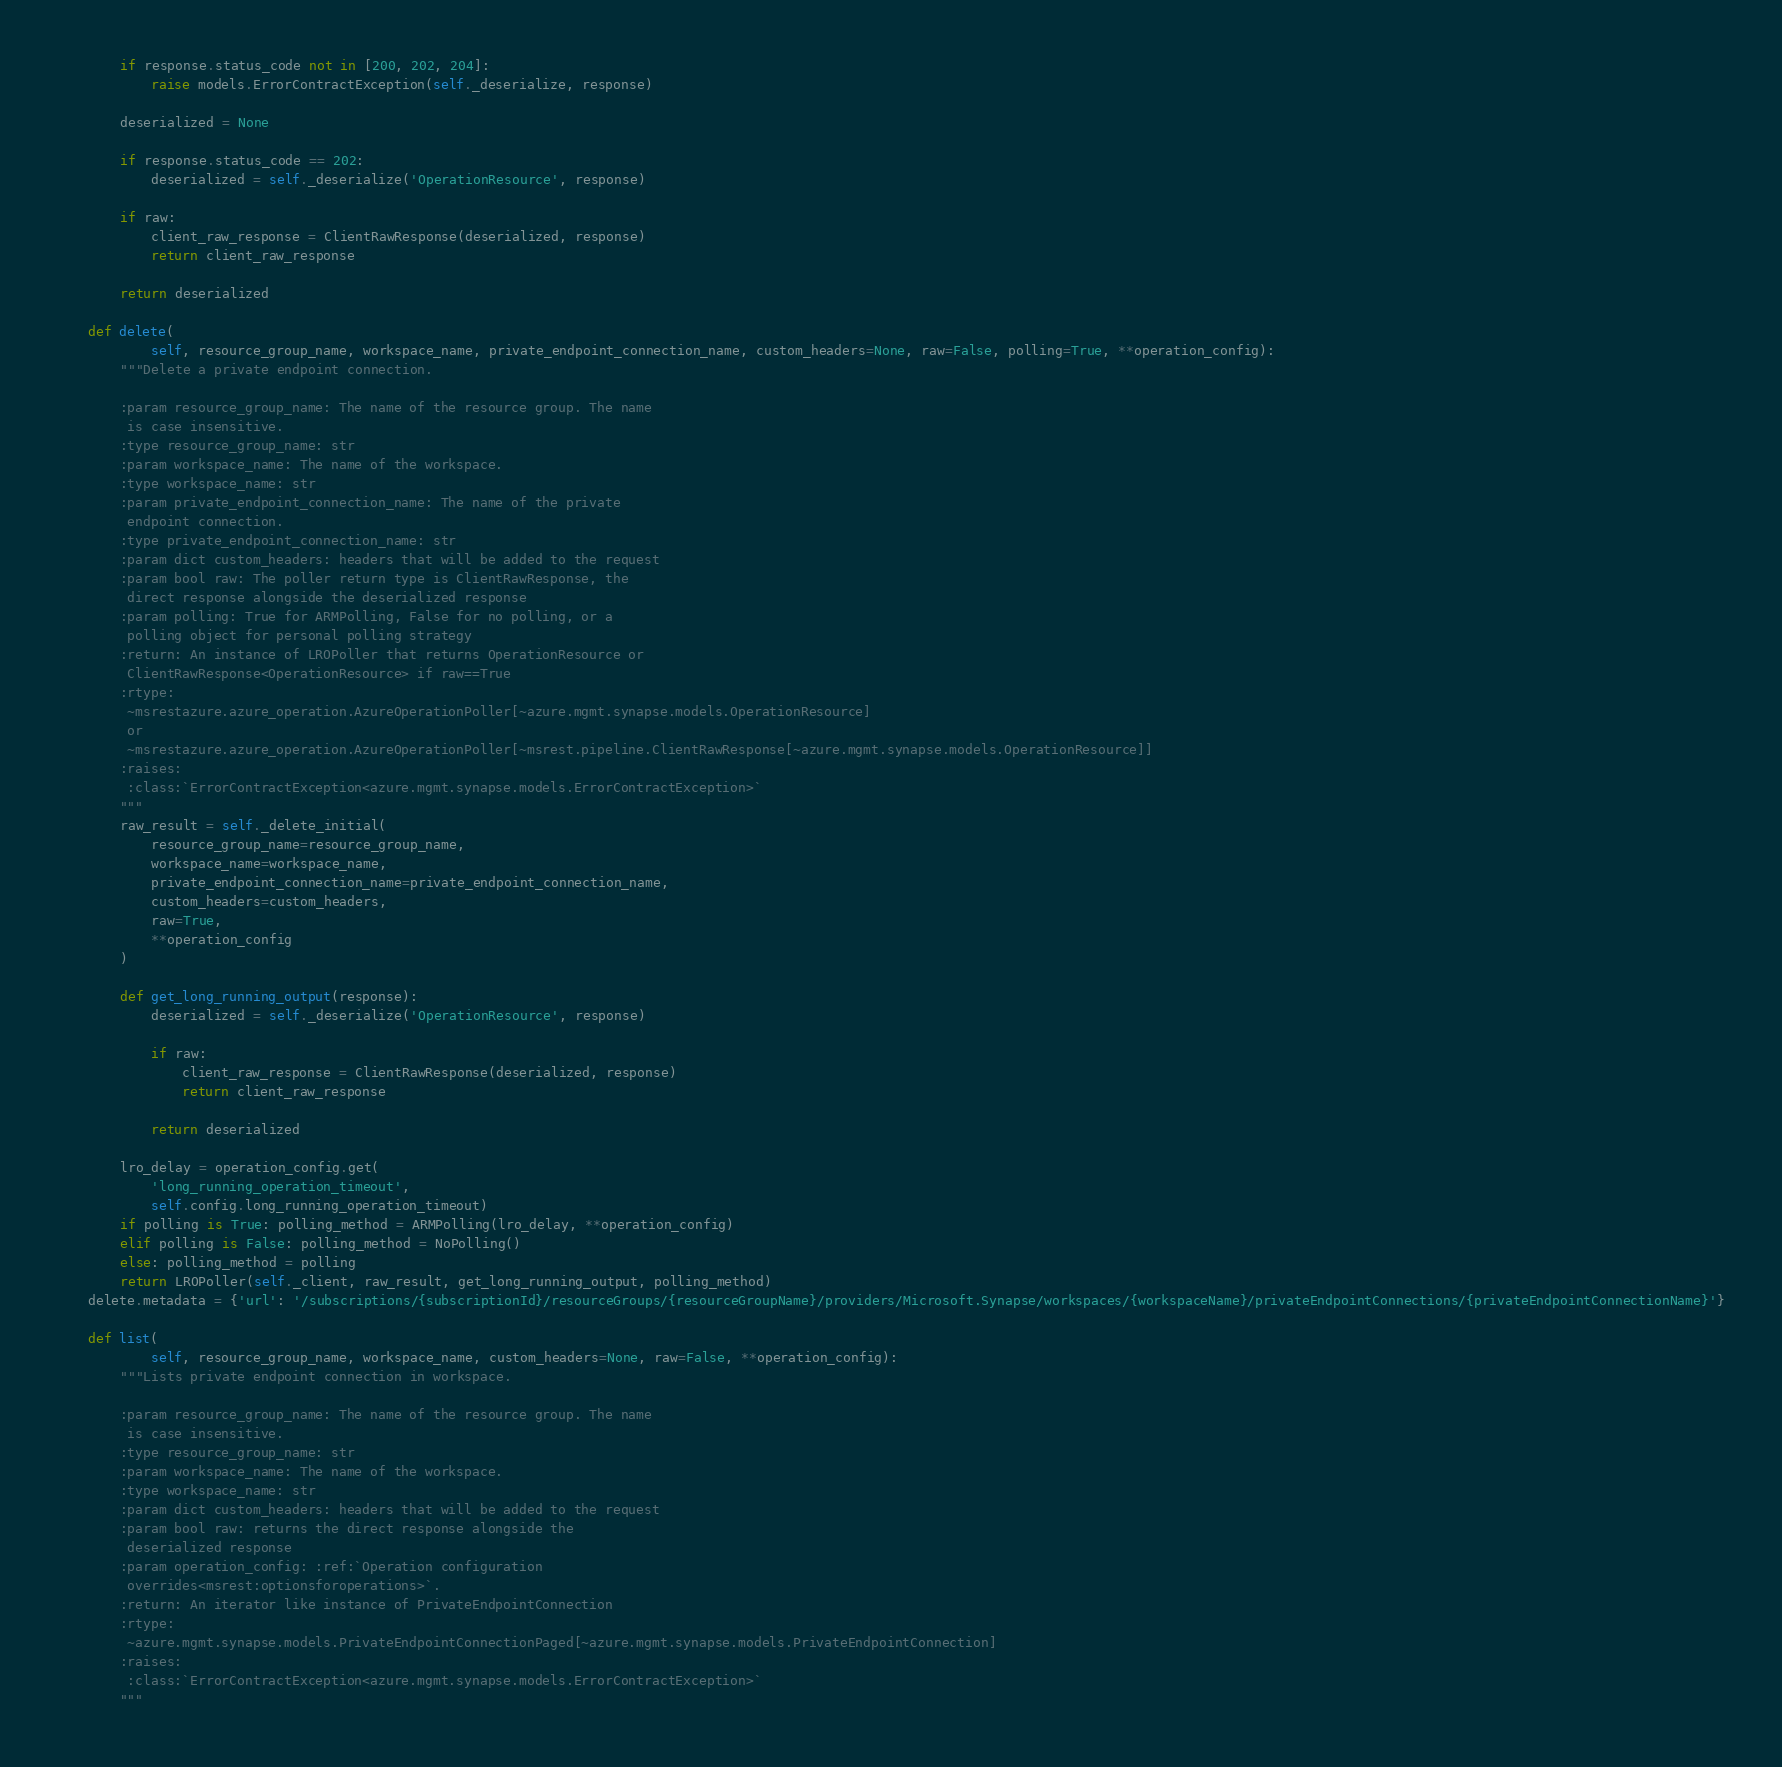Convert code to text. <code><loc_0><loc_0><loc_500><loc_500><_Python_>
        if response.status_code not in [200, 202, 204]:
            raise models.ErrorContractException(self._deserialize, response)

        deserialized = None

        if response.status_code == 202:
            deserialized = self._deserialize('OperationResource', response)

        if raw:
            client_raw_response = ClientRawResponse(deserialized, response)
            return client_raw_response

        return deserialized

    def delete(
            self, resource_group_name, workspace_name, private_endpoint_connection_name, custom_headers=None, raw=False, polling=True, **operation_config):
        """Delete a private endpoint connection.

        :param resource_group_name: The name of the resource group. The name
         is case insensitive.
        :type resource_group_name: str
        :param workspace_name: The name of the workspace.
        :type workspace_name: str
        :param private_endpoint_connection_name: The name of the private
         endpoint connection.
        :type private_endpoint_connection_name: str
        :param dict custom_headers: headers that will be added to the request
        :param bool raw: The poller return type is ClientRawResponse, the
         direct response alongside the deserialized response
        :param polling: True for ARMPolling, False for no polling, or a
         polling object for personal polling strategy
        :return: An instance of LROPoller that returns OperationResource or
         ClientRawResponse<OperationResource> if raw==True
        :rtype:
         ~msrestazure.azure_operation.AzureOperationPoller[~azure.mgmt.synapse.models.OperationResource]
         or
         ~msrestazure.azure_operation.AzureOperationPoller[~msrest.pipeline.ClientRawResponse[~azure.mgmt.synapse.models.OperationResource]]
        :raises:
         :class:`ErrorContractException<azure.mgmt.synapse.models.ErrorContractException>`
        """
        raw_result = self._delete_initial(
            resource_group_name=resource_group_name,
            workspace_name=workspace_name,
            private_endpoint_connection_name=private_endpoint_connection_name,
            custom_headers=custom_headers,
            raw=True,
            **operation_config
        )

        def get_long_running_output(response):
            deserialized = self._deserialize('OperationResource', response)

            if raw:
                client_raw_response = ClientRawResponse(deserialized, response)
                return client_raw_response

            return deserialized

        lro_delay = operation_config.get(
            'long_running_operation_timeout',
            self.config.long_running_operation_timeout)
        if polling is True: polling_method = ARMPolling(lro_delay, **operation_config)
        elif polling is False: polling_method = NoPolling()
        else: polling_method = polling
        return LROPoller(self._client, raw_result, get_long_running_output, polling_method)
    delete.metadata = {'url': '/subscriptions/{subscriptionId}/resourceGroups/{resourceGroupName}/providers/Microsoft.Synapse/workspaces/{workspaceName}/privateEndpointConnections/{privateEndpointConnectionName}'}

    def list(
            self, resource_group_name, workspace_name, custom_headers=None, raw=False, **operation_config):
        """Lists private endpoint connection in workspace.

        :param resource_group_name: The name of the resource group. The name
         is case insensitive.
        :type resource_group_name: str
        :param workspace_name: The name of the workspace.
        :type workspace_name: str
        :param dict custom_headers: headers that will be added to the request
        :param bool raw: returns the direct response alongside the
         deserialized response
        :param operation_config: :ref:`Operation configuration
         overrides<msrest:optionsforoperations>`.
        :return: An iterator like instance of PrivateEndpointConnection
        :rtype:
         ~azure.mgmt.synapse.models.PrivateEndpointConnectionPaged[~azure.mgmt.synapse.models.PrivateEndpointConnection]
        :raises:
         :class:`ErrorContractException<azure.mgmt.synapse.models.ErrorContractException>`
        """</code> 